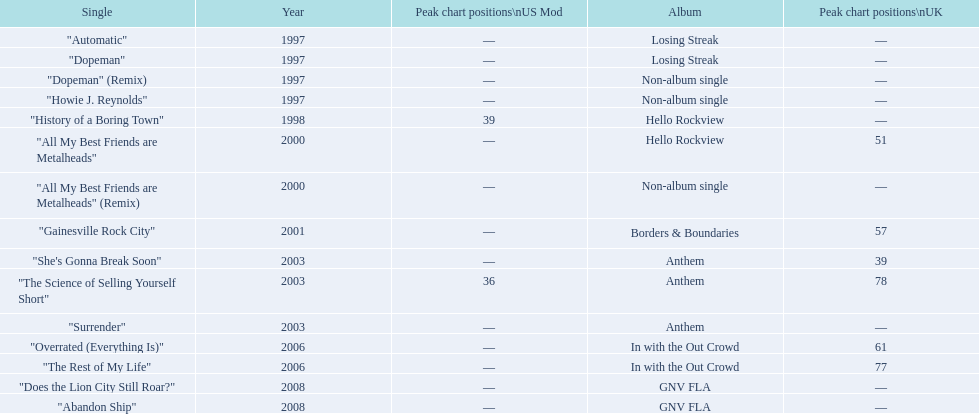Besides "dopeman," can you identify another single from the losing streak album? "Automatic". Would you mind parsing the complete table? {'header': ['Single', 'Year', 'Peak chart positions\\nUS Mod', 'Album', 'Peak chart positions\\nUK'], 'rows': [['"Automatic"', '1997', '—', 'Losing Streak', '—'], ['"Dopeman"', '1997', '—', 'Losing Streak', '—'], ['"Dopeman" (Remix)', '1997', '—', 'Non-album single', '—'], ['"Howie J. Reynolds"', '1997', '—', 'Non-album single', '—'], ['"History of a Boring Town"', '1998', '39', 'Hello Rockview', '—'], ['"All My Best Friends are Metalheads"', '2000', '—', 'Hello Rockview', '51'], ['"All My Best Friends are Metalheads" (Remix)', '2000', '—', 'Non-album single', '—'], ['"Gainesville Rock City"', '2001', '—', 'Borders & Boundaries', '57'], ['"She\'s Gonna Break Soon"', '2003', '—', 'Anthem', '39'], ['"The Science of Selling Yourself Short"', '2003', '36', 'Anthem', '78'], ['"Surrender"', '2003', '—', 'Anthem', '—'], ['"Overrated (Everything Is)"', '2006', '—', 'In with the Out Crowd', '61'], ['"The Rest of My Life"', '2006', '—', 'In with the Out Crowd', '77'], ['"Does the Lion City Still Roar?"', '2008', '—', 'GNV FLA', '—'], ['"Abandon Ship"', '2008', '—', 'GNV FLA', '—']]} 